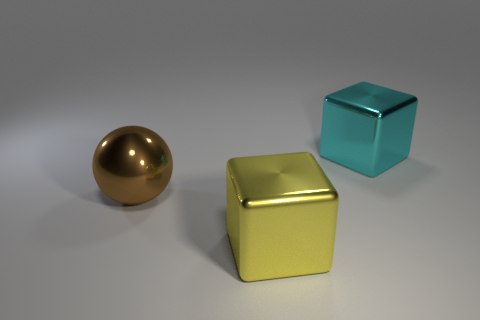Subtract all cubes. How many objects are left? 1 Subtract 1 cubes. How many cubes are left? 1 Add 1 small blue balls. How many objects exist? 4 Subtract all purple cylinders. How many yellow blocks are left? 1 Subtract all big yellow metal blocks. Subtract all big blue metal objects. How many objects are left? 2 Add 1 metallic cubes. How many metallic cubes are left? 3 Add 3 big cyan matte things. How many big cyan matte things exist? 3 Subtract 0 green blocks. How many objects are left? 3 Subtract all green spheres. Subtract all gray cubes. How many spheres are left? 1 